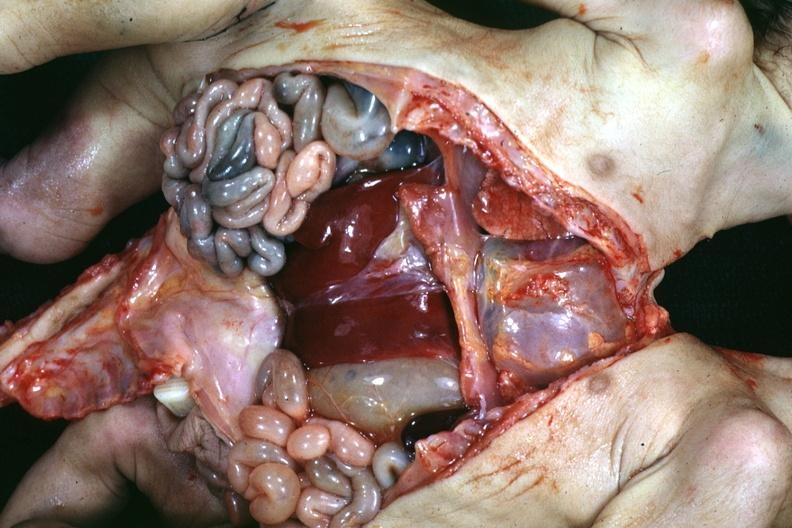what opened lower chest and abdomen showing apparent two sets intestine with one liver?
Answer the question using a single word or phrase. Lower anterior 